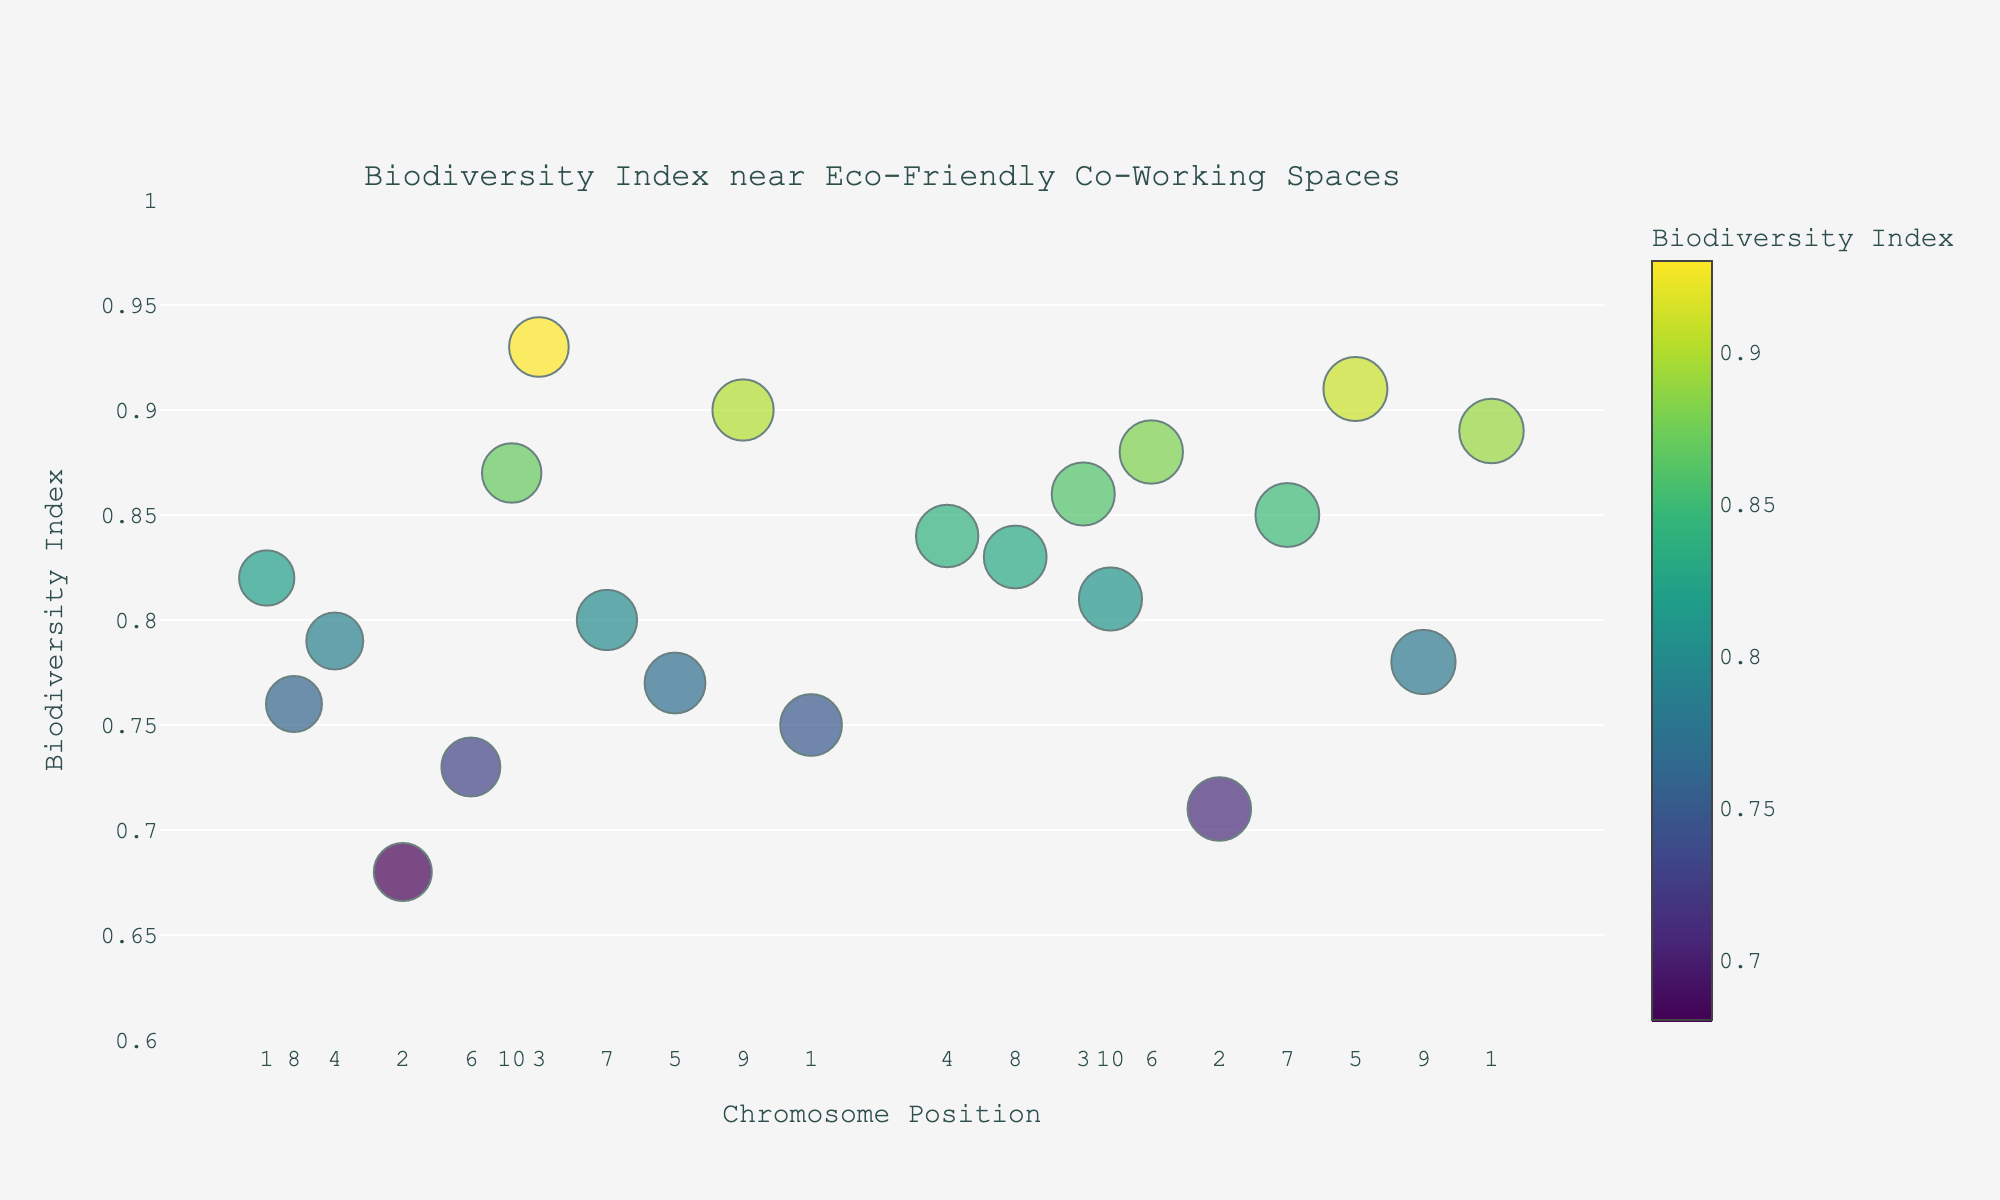What is the title of the plot? The title of the plot is displayed at the top center. It reads "Biodiversity Index near Eco-Friendly Co-Working Spaces".
Answer: Biodiversity Index near Eco-Friendly Co-Working Spaces What is the range of the y-axis in the figure? The y-axis is labeled as "Biodiversity Index" and its range spans from 0.6 to 1.0.
Answer: 0.6 to 1.0 Which data point has the highest Biodiversity Index, and what is its value? The data point with the highest y-value represents the highest Biodiversity Index. Upon inspection, Coconut Collab Costa Rica has the highest Biodiversity Index of 0.93.
Answer: Coconut Collab Costa Rica, 0.93 How many unique chromosomes are represented in the plot? Each data point is plotted on the x-axis with chromosome labels. By counting the tick labels, we see that chromosomes are represented from 1 to 10.
Answer: 10 Which location has the lowest Biodiversity Index? The data point with the lowest y-value indicates the lowest Biodiversity Index. Green Spaces New York has the lowest Biodiversity Index of 0.68.
Answer: Green Spaces New York What is the difference in Biodiversity Index between Impact Hub Tokyo and Remote Year Lisbon? Identify the Biodiversity Index for both locations. Impact Hub Tokyo has a Biodiversity Index of 0.75, and Remote Year Lisbon has a Biodiversity Index of 0.81. The difference is 0.81 - 0.75 = 0.06.
Answer: 0.06 Which location has the largest marker size, and what does it represent? The marker size is determined by the log of the chromosome position. The largest marker corresponds to the highest log(position). Punspace Chiang Mai on chromosome 9 has the highest position (9500000) yielding the largest marker size.
Answer: Punspace Chiang Mai How does the Biodiversity Index at Selina Medellin compare to that at Nest Copenhagen? Examine the y-values of both points. Selina Medellin has a Biodiversity Index of 0.80 and Nest Copenhagen 0.85, meaning Nest Copenhagen has a higher Biodiversity Index.
Answer: Nest Copenhagen has a higher Biodiversity Index What is the average Biodiversity Index of all locations on Chromosome 5? The locations on Chromosome 5 are Eco Hub Melbourne (0.77) and Outpost Ubud (0.91). \( (0.77 + 0.91) / 2 = 0.84 \).
Answer: 0.84 Are there any locations on Chromosome 4 with a Biodiversity Index above 0.80? Inspect the data points on Chromosome 4. Sustainable Valley Amsterdam has a Biodiversity Index of 0.79, and The Farm SoHo NYC 0.84. Only The Farm SoHo NYC has a Biodiversity Index above 0.80.
Answer: Yes, The Farm SoHo NYC 